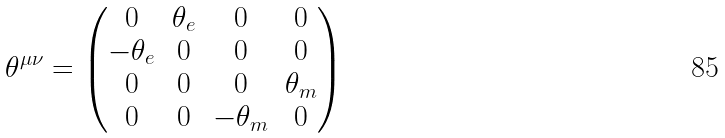Convert formula to latex. <formula><loc_0><loc_0><loc_500><loc_500>\theta ^ { \mu \nu } = \begin{pmatrix} 0 & \theta _ { e } & 0 & 0 \\ - \theta _ { e } & 0 & 0 & 0 \\ 0 & 0 & 0 & \theta _ { m } \\ 0 & 0 & - \theta _ { m } & 0 \end{pmatrix}</formula> 